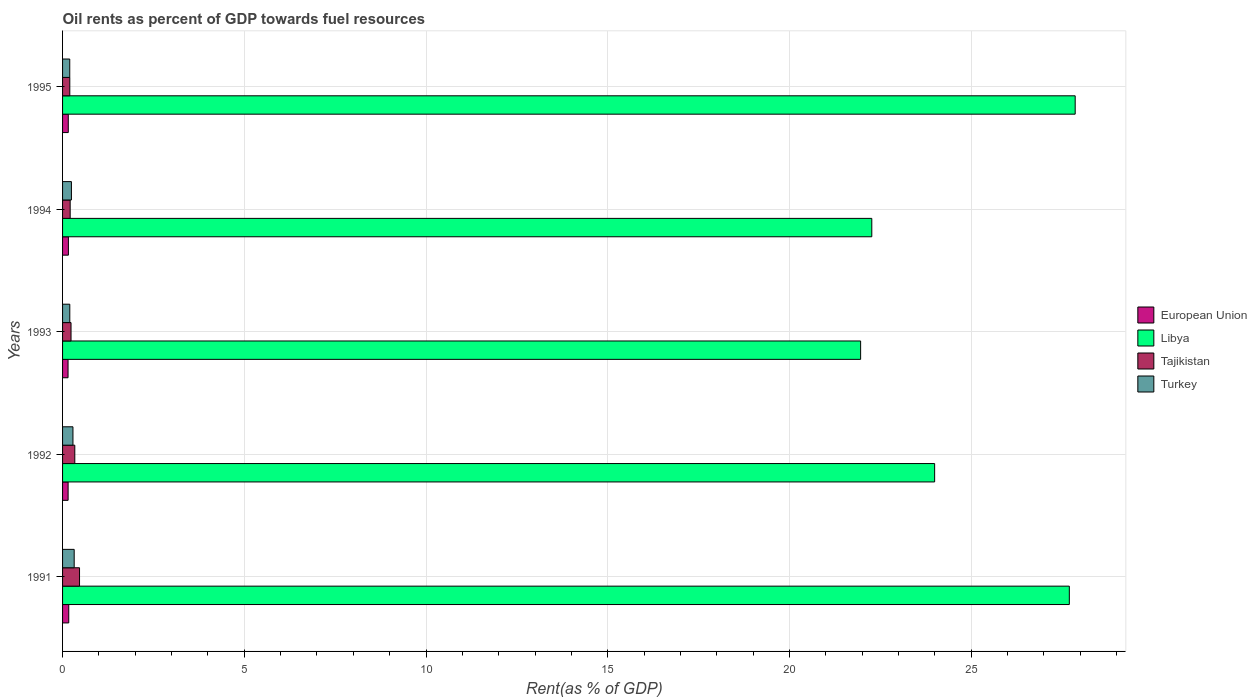How many different coloured bars are there?
Make the answer very short. 4. How many groups of bars are there?
Keep it short and to the point. 5. Are the number of bars per tick equal to the number of legend labels?
Ensure brevity in your answer.  Yes. What is the label of the 1st group of bars from the top?
Provide a short and direct response. 1995. What is the oil rent in Turkey in 1991?
Your response must be concise. 0.32. Across all years, what is the maximum oil rent in Tajikistan?
Ensure brevity in your answer.  0.47. Across all years, what is the minimum oil rent in Turkey?
Your answer should be compact. 0.2. In which year was the oil rent in Turkey minimum?
Provide a short and direct response. 1995. What is the total oil rent in Libya in the graph?
Offer a very short reply. 123.79. What is the difference between the oil rent in Tajikistan in 1993 and that in 1995?
Your answer should be compact. 0.03. What is the difference between the oil rent in Tajikistan in 1992 and the oil rent in Turkey in 1995?
Your answer should be compact. 0.14. What is the average oil rent in European Union per year?
Your answer should be very brief. 0.16. In the year 1993, what is the difference between the oil rent in European Union and oil rent in Libya?
Give a very brief answer. -21.81. In how many years, is the oil rent in European Union greater than 16 %?
Your answer should be very brief. 0. What is the ratio of the oil rent in Turkey in 1994 to that in 1995?
Make the answer very short. 1.23. Is the oil rent in European Union in 1991 less than that in 1992?
Offer a very short reply. No. What is the difference between the highest and the second highest oil rent in European Union?
Provide a succinct answer. 0.01. What is the difference between the highest and the lowest oil rent in Turkey?
Keep it short and to the point. 0.12. In how many years, is the oil rent in Turkey greater than the average oil rent in Turkey taken over all years?
Offer a very short reply. 2. What does the 2nd bar from the top in 1991 represents?
Ensure brevity in your answer.  Tajikistan. How many bars are there?
Your answer should be very brief. 20. Are the values on the major ticks of X-axis written in scientific E-notation?
Your response must be concise. No. Does the graph contain any zero values?
Your response must be concise. No. How are the legend labels stacked?
Your answer should be very brief. Vertical. What is the title of the graph?
Offer a terse response. Oil rents as percent of GDP towards fuel resources. Does "Japan" appear as one of the legend labels in the graph?
Your response must be concise. No. What is the label or title of the X-axis?
Offer a very short reply. Rent(as % of GDP). What is the label or title of the Y-axis?
Provide a succinct answer. Years. What is the Rent(as % of GDP) in European Union in 1991?
Offer a very short reply. 0.17. What is the Rent(as % of GDP) in Libya in 1991?
Give a very brief answer. 27.7. What is the Rent(as % of GDP) of Tajikistan in 1991?
Offer a very short reply. 0.47. What is the Rent(as % of GDP) of Turkey in 1991?
Your response must be concise. 0.32. What is the Rent(as % of GDP) in European Union in 1992?
Your answer should be very brief. 0.15. What is the Rent(as % of GDP) of Libya in 1992?
Give a very brief answer. 24. What is the Rent(as % of GDP) of Tajikistan in 1992?
Keep it short and to the point. 0.34. What is the Rent(as % of GDP) of Turkey in 1992?
Offer a very short reply. 0.29. What is the Rent(as % of GDP) in European Union in 1993?
Your answer should be compact. 0.15. What is the Rent(as % of GDP) in Libya in 1993?
Provide a short and direct response. 21.96. What is the Rent(as % of GDP) of Tajikistan in 1993?
Make the answer very short. 0.23. What is the Rent(as % of GDP) of Turkey in 1993?
Your answer should be compact. 0.2. What is the Rent(as % of GDP) in European Union in 1994?
Your answer should be compact. 0.16. What is the Rent(as % of GDP) in Libya in 1994?
Your response must be concise. 22.27. What is the Rent(as % of GDP) of Tajikistan in 1994?
Offer a very short reply. 0.21. What is the Rent(as % of GDP) of Turkey in 1994?
Provide a short and direct response. 0.24. What is the Rent(as % of GDP) in European Union in 1995?
Provide a succinct answer. 0.16. What is the Rent(as % of GDP) of Libya in 1995?
Offer a very short reply. 27.86. What is the Rent(as % of GDP) of Tajikistan in 1995?
Your response must be concise. 0.2. What is the Rent(as % of GDP) of Turkey in 1995?
Give a very brief answer. 0.2. Across all years, what is the maximum Rent(as % of GDP) in European Union?
Your response must be concise. 0.17. Across all years, what is the maximum Rent(as % of GDP) in Libya?
Your response must be concise. 27.86. Across all years, what is the maximum Rent(as % of GDP) in Tajikistan?
Keep it short and to the point. 0.47. Across all years, what is the maximum Rent(as % of GDP) in Turkey?
Provide a short and direct response. 0.32. Across all years, what is the minimum Rent(as % of GDP) in European Union?
Your response must be concise. 0.15. Across all years, what is the minimum Rent(as % of GDP) in Libya?
Offer a very short reply. 21.96. Across all years, what is the minimum Rent(as % of GDP) in Tajikistan?
Offer a very short reply. 0.2. Across all years, what is the minimum Rent(as % of GDP) of Turkey?
Your response must be concise. 0.2. What is the total Rent(as % of GDP) in European Union in the graph?
Offer a very short reply. 0.79. What is the total Rent(as % of GDP) of Libya in the graph?
Give a very brief answer. 123.79. What is the total Rent(as % of GDP) in Tajikistan in the graph?
Offer a very short reply. 1.44. What is the total Rent(as % of GDP) in Turkey in the graph?
Provide a succinct answer. 1.25. What is the difference between the Rent(as % of GDP) in European Union in 1991 and that in 1992?
Provide a short and direct response. 0.02. What is the difference between the Rent(as % of GDP) of Libya in 1991 and that in 1992?
Your answer should be compact. 3.71. What is the difference between the Rent(as % of GDP) of Tajikistan in 1991 and that in 1992?
Offer a very short reply. 0.13. What is the difference between the Rent(as % of GDP) in Turkey in 1991 and that in 1992?
Ensure brevity in your answer.  0.03. What is the difference between the Rent(as % of GDP) in European Union in 1991 and that in 1993?
Your answer should be compact. 0.02. What is the difference between the Rent(as % of GDP) in Libya in 1991 and that in 1993?
Your response must be concise. 5.74. What is the difference between the Rent(as % of GDP) in Tajikistan in 1991 and that in 1993?
Provide a short and direct response. 0.23. What is the difference between the Rent(as % of GDP) in Turkey in 1991 and that in 1993?
Provide a succinct answer. 0.12. What is the difference between the Rent(as % of GDP) in European Union in 1991 and that in 1994?
Offer a terse response. 0.01. What is the difference between the Rent(as % of GDP) of Libya in 1991 and that in 1994?
Your answer should be very brief. 5.43. What is the difference between the Rent(as % of GDP) in Tajikistan in 1991 and that in 1994?
Make the answer very short. 0.26. What is the difference between the Rent(as % of GDP) of Turkey in 1991 and that in 1994?
Your response must be concise. 0.08. What is the difference between the Rent(as % of GDP) in European Union in 1991 and that in 1995?
Your answer should be compact. 0.01. What is the difference between the Rent(as % of GDP) of Libya in 1991 and that in 1995?
Provide a succinct answer. -0.16. What is the difference between the Rent(as % of GDP) of Tajikistan in 1991 and that in 1995?
Offer a very short reply. 0.27. What is the difference between the Rent(as % of GDP) in Turkey in 1991 and that in 1995?
Give a very brief answer. 0.12. What is the difference between the Rent(as % of GDP) in European Union in 1992 and that in 1993?
Make the answer very short. 0. What is the difference between the Rent(as % of GDP) of Libya in 1992 and that in 1993?
Keep it short and to the point. 2.04. What is the difference between the Rent(as % of GDP) in Tajikistan in 1992 and that in 1993?
Your answer should be very brief. 0.1. What is the difference between the Rent(as % of GDP) of Turkey in 1992 and that in 1993?
Offer a terse response. 0.09. What is the difference between the Rent(as % of GDP) of European Union in 1992 and that in 1994?
Offer a very short reply. -0.01. What is the difference between the Rent(as % of GDP) in Libya in 1992 and that in 1994?
Your answer should be compact. 1.73. What is the difference between the Rent(as % of GDP) of Tajikistan in 1992 and that in 1994?
Keep it short and to the point. 0.13. What is the difference between the Rent(as % of GDP) in Turkey in 1992 and that in 1994?
Give a very brief answer. 0.04. What is the difference between the Rent(as % of GDP) in European Union in 1992 and that in 1995?
Your response must be concise. -0. What is the difference between the Rent(as % of GDP) of Libya in 1992 and that in 1995?
Your response must be concise. -3.87. What is the difference between the Rent(as % of GDP) of Tajikistan in 1992 and that in 1995?
Ensure brevity in your answer.  0.14. What is the difference between the Rent(as % of GDP) in Turkey in 1992 and that in 1995?
Ensure brevity in your answer.  0.09. What is the difference between the Rent(as % of GDP) of European Union in 1993 and that in 1994?
Ensure brevity in your answer.  -0.01. What is the difference between the Rent(as % of GDP) in Libya in 1993 and that in 1994?
Ensure brevity in your answer.  -0.31. What is the difference between the Rent(as % of GDP) of Tajikistan in 1993 and that in 1994?
Make the answer very short. 0.02. What is the difference between the Rent(as % of GDP) in Turkey in 1993 and that in 1994?
Make the answer very short. -0.04. What is the difference between the Rent(as % of GDP) of European Union in 1993 and that in 1995?
Provide a short and direct response. -0.01. What is the difference between the Rent(as % of GDP) of Libya in 1993 and that in 1995?
Your answer should be very brief. -5.9. What is the difference between the Rent(as % of GDP) of Tajikistan in 1993 and that in 1995?
Your answer should be very brief. 0.03. What is the difference between the Rent(as % of GDP) in Turkey in 1993 and that in 1995?
Keep it short and to the point. 0. What is the difference between the Rent(as % of GDP) of European Union in 1994 and that in 1995?
Your response must be concise. 0. What is the difference between the Rent(as % of GDP) in Libya in 1994 and that in 1995?
Your response must be concise. -5.6. What is the difference between the Rent(as % of GDP) of Tajikistan in 1994 and that in 1995?
Your answer should be very brief. 0.01. What is the difference between the Rent(as % of GDP) in Turkey in 1994 and that in 1995?
Your response must be concise. 0.05. What is the difference between the Rent(as % of GDP) in European Union in 1991 and the Rent(as % of GDP) in Libya in 1992?
Offer a terse response. -23.83. What is the difference between the Rent(as % of GDP) of European Union in 1991 and the Rent(as % of GDP) of Tajikistan in 1992?
Provide a short and direct response. -0.17. What is the difference between the Rent(as % of GDP) in European Union in 1991 and the Rent(as % of GDP) in Turkey in 1992?
Make the answer very short. -0.12. What is the difference between the Rent(as % of GDP) in Libya in 1991 and the Rent(as % of GDP) in Tajikistan in 1992?
Your answer should be very brief. 27.37. What is the difference between the Rent(as % of GDP) in Libya in 1991 and the Rent(as % of GDP) in Turkey in 1992?
Ensure brevity in your answer.  27.42. What is the difference between the Rent(as % of GDP) in Tajikistan in 1991 and the Rent(as % of GDP) in Turkey in 1992?
Provide a succinct answer. 0.18. What is the difference between the Rent(as % of GDP) of European Union in 1991 and the Rent(as % of GDP) of Libya in 1993?
Offer a very short reply. -21.79. What is the difference between the Rent(as % of GDP) of European Union in 1991 and the Rent(as % of GDP) of Tajikistan in 1993?
Ensure brevity in your answer.  -0.06. What is the difference between the Rent(as % of GDP) of European Union in 1991 and the Rent(as % of GDP) of Turkey in 1993?
Make the answer very short. -0.03. What is the difference between the Rent(as % of GDP) in Libya in 1991 and the Rent(as % of GDP) in Tajikistan in 1993?
Keep it short and to the point. 27.47. What is the difference between the Rent(as % of GDP) in Libya in 1991 and the Rent(as % of GDP) in Turkey in 1993?
Offer a terse response. 27.5. What is the difference between the Rent(as % of GDP) of Tajikistan in 1991 and the Rent(as % of GDP) of Turkey in 1993?
Ensure brevity in your answer.  0.27. What is the difference between the Rent(as % of GDP) of European Union in 1991 and the Rent(as % of GDP) of Libya in 1994?
Your answer should be compact. -22.1. What is the difference between the Rent(as % of GDP) of European Union in 1991 and the Rent(as % of GDP) of Tajikistan in 1994?
Make the answer very short. -0.04. What is the difference between the Rent(as % of GDP) of European Union in 1991 and the Rent(as % of GDP) of Turkey in 1994?
Ensure brevity in your answer.  -0.07. What is the difference between the Rent(as % of GDP) of Libya in 1991 and the Rent(as % of GDP) of Tajikistan in 1994?
Offer a terse response. 27.49. What is the difference between the Rent(as % of GDP) of Libya in 1991 and the Rent(as % of GDP) of Turkey in 1994?
Make the answer very short. 27.46. What is the difference between the Rent(as % of GDP) in Tajikistan in 1991 and the Rent(as % of GDP) in Turkey in 1994?
Ensure brevity in your answer.  0.22. What is the difference between the Rent(as % of GDP) of European Union in 1991 and the Rent(as % of GDP) of Libya in 1995?
Your response must be concise. -27.69. What is the difference between the Rent(as % of GDP) in European Union in 1991 and the Rent(as % of GDP) in Tajikistan in 1995?
Your response must be concise. -0.03. What is the difference between the Rent(as % of GDP) of European Union in 1991 and the Rent(as % of GDP) of Turkey in 1995?
Ensure brevity in your answer.  -0.03. What is the difference between the Rent(as % of GDP) in Libya in 1991 and the Rent(as % of GDP) in Tajikistan in 1995?
Ensure brevity in your answer.  27.5. What is the difference between the Rent(as % of GDP) in Libya in 1991 and the Rent(as % of GDP) in Turkey in 1995?
Your response must be concise. 27.5. What is the difference between the Rent(as % of GDP) in Tajikistan in 1991 and the Rent(as % of GDP) in Turkey in 1995?
Ensure brevity in your answer.  0.27. What is the difference between the Rent(as % of GDP) of European Union in 1992 and the Rent(as % of GDP) of Libya in 1993?
Your answer should be very brief. -21.81. What is the difference between the Rent(as % of GDP) of European Union in 1992 and the Rent(as % of GDP) of Tajikistan in 1993?
Provide a succinct answer. -0.08. What is the difference between the Rent(as % of GDP) in European Union in 1992 and the Rent(as % of GDP) in Turkey in 1993?
Offer a very short reply. -0.05. What is the difference between the Rent(as % of GDP) of Libya in 1992 and the Rent(as % of GDP) of Tajikistan in 1993?
Your response must be concise. 23.76. What is the difference between the Rent(as % of GDP) of Libya in 1992 and the Rent(as % of GDP) of Turkey in 1993?
Give a very brief answer. 23.8. What is the difference between the Rent(as % of GDP) in Tajikistan in 1992 and the Rent(as % of GDP) in Turkey in 1993?
Give a very brief answer. 0.14. What is the difference between the Rent(as % of GDP) in European Union in 1992 and the Rent(as % of GDP) in Libya in 1994?
Ensure brevity in your answer.  -22.11. What is the difference between the Rent(as % of GDP) in European Union in 1992 and the Rent(as % of GDP) in Tajikistan in 1994?
Give a very brief answer. -0.06. What is the difference between the Rent(as % of GDP) in European Union in 1992 and the Rent(as % of GDP) in Turkey in 1994?
Make the answer very short. -0.09. What is the difference between the Rent(as % of GDP) in Libya in 1992 and the Rent(as % of GDP) in Tajikistan in 1994?
Your answer should be compact. 23.79. What is the difference between the Rent(as % of GDP) of Libya in 1992 and the Rent(as % of GDP) of Turkey in 1994?
Keep it short and to the point. 23.75. What is the difference between the Rent(as % of GDP) in Tajikistan in 1992 and the Rent(as % of GDP) in Turkey in 1994?
Provide a succinct answer. 0.09. What is the difference between the Rent(as % of GDP) in European Union in 1992 and the Rent(as % of GDP) in Libya in 1995?
Provide a short and direct response. -27.71. What is the difference between the Rent(as % of GDP) of European Union in 1992 and the Rent(as % of GDP) of Tajikistan in 1995?
Make the answer very short. -0.05. What is the difference between the Rent(as % of GDP) of European Union in 1992 and the Rent(as % of GDP) of Turkey in 1995?
Ensure brevity in your answer.  -0.04. What is the difference between the Rent(as % of GDP) in Libya in 1992 and the Rent(as % of GDP) in Tajikistan in 1995?
Provide a short and direct response. 23.8. What is the difference between the Rent(as % of GDP) in Libya in 1992 and the Rent(as % of GDP) in Turkey in 1995?
Ensure brevity in your answer.  23.8. What is the difference between the Rent(as % of GDP) of Tajikistan in 1992 and the Rent(as % of GDP) of Turkey in 1995?
Provide a succinct answer. 0.14. What is the difference between the Rent(as % of GDP) in European Union in 1993 and the Rent(as % of GDP) in Libya in 1994?
Keep it short and to the point. -22.12. What is the difference between the Rent(as % of GDP) of European Union in 1993 and the Rent(as % of GDP) of Tajikistan in 1994?
Your answer should be very brief. -0.06. What is the difference between the Rent(as % of GDP) of European Union in 1993 and the Rent(as % of GDP) of Turkey in 1994?
Provide a short and direct response. -0.09. What is the difference between the Rent(as % of GDP) of Libya in 1993 and the Rent(as % of GDP) of Tajikistan in 1994?
Make the answer very short. 21.75. What is the difference between the Rent(as % of GDP) in Libya in 1993 and the Rent(as % of GDP) in Turkey in 1994?
Give a very brief answer. 21.72. What is the difference between the Rent(as % of GDP) of Tajikistan in 1993 and the Rent(as % of GDP) of Turkey in 1994?
Make the answer very short. -0.01. What is the difference between the Rent(as % of GDP) in European Union in 1993 and the Rent(as % of GDP) in Libya in 1995?
Keep it short and to the point. -27.71. What is the difference between the Rent(as % of GDP) in European Union in 1993 and the Rent(as % of GDP) in Tajikistan in 1995?
Offer a terse response. -0.05. What is the difference between the Rent(as % of GDP) in European Union in 1993 and the Rent(as % of GDP) in Turkey in 1995?
Provide a succinct answer. -0.05. What is the difference between the Rent(as % of GDP) in Libya in 1993 and the Rent(as % of GDP) in Tajikistan in 1995?
Provide a succinct answer. 21.76. What is the difference between the Rent(as % of GDP) in Libya in 1993 and the Rent(as % of GDP) in Turkey in 1995?
Your response must be concise. 21.76. What is the difference between the Rent(as % of GDP) of Tajikistan in 1993 and the Rent(as % of GDP) of Turkey in 1995?
Your response must be concise. 0.04. What is the difference between the Rent(as % of GDP) of European Union in 1994 and the Rent(as % of GDP) of Libya in 1995?
Offer a terse response. -27.7. What is the difference between the Rent(as % of GDP) in European Union in 1994 and the Rent(as % of GDP) in Tajikistan in 1995?
Provide a short and direct response. -0.04. What is the difference between the Rent(as % of GDP) of European Union in 1994 and the Rent(as % of GDP) of Turkey in 1995?
Keep it short and to the point. -0.04. What is the difference between the Rent(as % of GDP) of Libya in 1994 and the Rent(as % of GDP) of Tajikistan in 1995?
Give a very brief answer. 22.07. What is the difference between the Rent(as % of GDP) of Libya in 1994 and the Rent(as % of GDP) of Turkey in 1995?
Your response must be concise. 22.07. What is the difference between the Rent(as % of GDP) in Tajikistan in 1994 and the Rent(as % of GDP) in Turkey in 1995?
Provide a short and direct response. 0.01. What is the average Rent(as % of GDP) in European Union per year?
Make the answer very short. 0.16. What is the average Rent(as % of GDP) of Libya per year?
Keep it short and to the point. 24.76. What is the average Rent(as % of GDP) in Tajikistan per year?
Make the answer very short. 0.29. What is the average Rent(as % of GDP) of Turkey per year?
Give a very brief answer. 0.25. In the year 1991, what is the difference between the Rent(as % of GDP) in European Union and Rent(as % of GDP) in Libya?
Your answer should be compact. -27.53. In the year 1991, what is the difference between the Rent(as % of GDP) of European Union and Rent(as % of GDP) of Tajikistan?
Keep it short and to the point. -0.3. In the year 1991, what is the difference between the Rent(as % of GDP) of European Union and Rent(as % of GDP) of Turkey?
Your response must be concise. -0.15. In the year 1991, what is the difference between the Rent(as % of GDP) in Libya and Rent(as % of GDP) in Tajikistan?
Keep it short and to the point. 27.23. In the year 1991, what is the difference between the Rent(as % of GDP) in Libya and Rent(as % of GDP) in Turkey?
Keep it short and to the point. 27.38. In the year 1991, what is the difference between the Rent(as % of GDP) in Tajikistan and Rent(as % of GDP) in Turkey?
Offer a terse response. 0.15. In the year 1992, what is the difference between the Rent(as % of GDP) in European Union and Rent(as % of GDP) in Libya?
Offer a very short reply. -23.84. In the year 1992, what is the difference between the Rent(as % of GDP) in European Union and Rent(as % of GDP) in Tajikistan?
Offer a terse response. -0.18. In the year 1992, what is the difference between the Rent(as % of GDP) in European Union and Rent(as % of GDP) in Turkey?
Provide a short and direct response. -0.13. In the year 1992, what is the difference between the Rent(as % of GDP) of Libya and Rent(as % of GDP) of Tajikistan?
Give a very brief answer. 23.66. In the year 1992, what is the difference between the Rent(as % of GDP) of Libya and Rent(as % of GDP) of Turkey?
Ensure brevity in your answer.  23.71. In the year 1992, what is the difference between the Rent(as % of GDP) of Tajikistan and Rent(as % of GDP) of Turkey?
Offer a very short reply. 0.05. In the year 1993, what is the difference between the Rent(as % of GDP) in European Union and Rent(as % of GDP) in Libya?
Ensure brevity in your answer.  -21.81. In the year 1993, what is the difference between the Rent(as % of GDP) of European Union and Rent(as % of GDP) of Tajikistan?
Give a very brief answer. -0.08. In the year 1993, what is the difference between the Rent(as % of GDP) of European Union and Rent(as % of GDP) of Turkey?
Provide a short and direct response. -0.05. In the year 1993, what is the difference between the Rent(as % of GDP) of Libya and Rent(as % of GDP) of Tajikistan?
Your answer should be compact. 21.73. In the year 1993, what is the difference between the Rent(as % of GDP) in Libya and Rent(as % of GDP) in Turkey?
Offer a terse response. 21.76. In the year 1993, what is the difference between the Rent(as % of GDP) in Tajikistan and Rent(as % of GDP) in Turkey?
Your answer should be compact. 0.03. In the year 1994, what is the difference between the Rent(as % of GDP) in European Union and Rent(as % of GDP) in Libya?
Provide a succinct answer. -22.11. In the year 1994, what is the difference between the Rent(as % of GDP) in European Union and Rent(as % of GDP) in Tajikistan?
Your response must be concise. -0.05. In the year 1994, what is the difference between the Rent(as % of GDP) in European Union and Rent(as % of GDP) in Turkey?
Your response must be concise. -0.08. In the year 1994, what is the difference between the Rent(as % of GDP) in Libya and Rent(as % of GDP) in Tajikistan?
Provide a short and direct response. 22.06. In the year 1994, what is the difference between the Rent(as % of GDP) of Libya and Rent(as % of GDP) of Turkey?
Your answer should be compact. 22.02. In the year 1994, what is the difference between the Rent(as % of GDP) of Tajikistan and Rent(as % of GDP) of Turkey?
Offer a terse response. -0.03. In the year 1995, what is the difference between the Rent(as % of GDP) of European Union and Rent(as % of GDP) of Libya?
Provide a succinct answer. -27.71. In the year 1995, what is the difference between the Rent(as % of GDP) in European Union and Rent(as % of GDP) in Tajikistan?
Your response must be concise. -0.04. In the year 1995, what is the difference between the Rent(as % of GDP) of European Union and Rent(as % of GDP) of Turkey?
Ensure brevity in your answer.  -0.04. In the year 1995, what is the difference between the Rent(as % of GDP) in Libya and Rent(as % of GDP) in Tajikistan?
Give a very brief answer. 27.66. In the year 1995, what is the difference between the Rent(as % of GDP) in Libya and Rent(as % of GDP) in Turkey?
Give a very brief answer. 27.67. In the year 1995, what is the difference between the Rent(as % of GDP) of Tajikistan and Rent(as % of GDP) of Turkey?
Your response must be concise. 0. What is the ratio of the Rent(as % of GDP) of European Union in 1991 to that in 1992?
Your response must be concise. 1.11. What is the ratio of the Rent(as % of GDP) of Libya in 1991 to that in 1992?
Ensure brevity in your answer.  1.15. What is the ratio of the Rent(as % of GDP) in Tajikistan in 1991 to that in 1992?
Keep it short and to the point. 1.39. What is the ratio of the Rent(as % of GDP) in Turkey in 1991 to that in 1992?
Make the answer very short. 1.12. What is the ratio of the Rent(as % of GDP) in European Union in 1991 to that in 1993?
Provide a succinct answer. 1.13. What is the ratio of the Rent(as % of GDP) of Libya in 1991 to that in 1993?
Offer a terse response. 1.26. What is the ratio of the Rent(as % of GDP) of Tajikistan in 1991 to that in 1993?
Give a very brief answer. 2. What is the ratio of the Rent(as % of GDP) in Turkey in 1991 to that in 1993?
Keep it short and to the point. 1.61. What is the ratio of the Rent(as % of GDP) in European Union in 1991 to that in 1994?
Your response must be concise. 1.06. What is the ratio of the Rent(as % of GDP) of Libya in 1991 to that in 1994?
Provide a succinct answer. 1.24. What is the ratio of the Rent(as % of GDP) in Tajikistan in 1991 to that in 1994?
Your answer should be compact. 2.23. What is the ratio of the Rent(as % of GDP) of Turkey in 1991 to that in 1994?
Offer a terse response. 1.31. What is the ratio of the Rent(as % of GDP) in European Union in 1991 to that in 1995?
Your response must be concise. 1.08. What is the ratio of the Rent(as % of GDP) of Libya in 1991 to that in 1995?
Offer a terse response. 0.99. What is the ratio of the Rent(as % of GDP) in Tajikistan in 1991 to that in 1995?
Make the answer very short. 2.35. What is the ratio of the Rent(as % of GDP) of Turkey in 1991 to that in 1995?
Your answer should be very brief. 1.62. What is the ratio of the Rent(as % of GDP) in European Union in 1992 to that in 1993?
Your answer should be compact. 1.01. What is the ratio of the Rent(as % of GDP) in Libya in 1992 to that in 1993?
Your response must be concise. 1.09. What is the ratio of the Rent(as % of GDP) of Tajikistan in 1992 to that in 1993?
Your response must be concise. 1.44. What is the ratio of the Rent(as % of GDP) in Turkey in 1992 to that in 1993?
Give a very brief answer. 1.44. What is the ratio of the Rent(as % of GDP) in European Union in 1992 to that in 1994?
Provide a succinct answer. 0.95. What is the ratio of the Rent(as % of GDP) in Libya in 1992 to that in 1994?
Give a very brief answer. 1.08. What is the ratio of the Rent(as % of GDP) in Tajikistan in 1992 to that in 1994?
Your answer should be compact. 1.61. What is the ratio of the Rent(as % of GDP) of Turkey in 1992 to that in 1994?
Your answer should be very brief. 1.17. What is the ratio of the Rent(as % of GDP) of European Union in 1992 to that in 1995?
Make the answer very short. 0.97. What is the ratio of the Rent(as % of GDP) of Libya in 1992 to that in 1995?
Your response must be concise. 0.86. What is the ratio of the Rent(as % of GDP) of Tajikistan in 1992 to that in 1995?
Ensure brevity in your answer.  1.69. What is the ratio of the Rent(as % of GDP) of Turkey in 1992 to that in 1995?
Offer a very short reply. 1.45. What is the ratio of the Rent(as % of GDP) in European Union in 1993 to that in 1994?
Make the answer very short. 0.94. What is the ratio of the Rent(as % of GDP) in Libya in 1993 to that in 1994?
Make the answer very short. 0.99. What is the ratio of the Rent(as % of GDP) in Tajikistan in 1993 to that in 1994?
Ensure brevity in your answer.  1.11. What is the ratio of the Rent(as % of GDP) in Turkey in 1993 to that in 1994?
Make the answer very short. 0.82. What is the ratio of the Rent(as % of GDP) in European Union in 1993 to that in 1995?
Give a very brief answer. 0.96. What is the ratio of the Rent(as % of GDP) of Libya in 1993 to that in 1995?
Your response must be concise. 0.79. What is the ratio of the Rent(as % of GDP) of Tajikistan in 1993 to that in 1995?
Your answer should be very brief. 1.17. What is the ratio of the Rent(as % of GDP) of Turkey in 1993 to that in 1995?
Your response must be concise. 1.01. What is the ratio of the Rent(as % of GDP) in European Union in 1994 to that in 1995?
Make the answer very short. 1.02. What is the ratio of the Rent(as % of GDP) of Libya in 1994 to that in 1995?
Keep it short and to the point. 0.8. What is the ratio of the Rent(as % of GDP) of Tajikistan in 1994 to that in 1995?
Your answer should be very brief. 1.05. What is the ratio of the Rent(as % of GDP) in Turkey in 1994 to that in 1995?
Offer a terse response. 1.23. What is the difference between the highest and the second highest Rent(as % of GDP) of European Union?
Make the answer very short. 0.01. What is the difference between the highest and the second highest Rent(as % of GDP) in Libya?
Keep it short and to the point. 0.16. What is the difference between the highest and the second highest Rent(as % of GDP) of Tajikistan?
Your answer should be very brief. 0.13. What is the difference between the highest and the second highest Rent(as % of GDP) of Turkey?
Give a very brief answer. 0.03. What is the difference between the highest and the lowest Rent(as % of GDP) in European Union?
Offer a terse response. 0.02. What is the difference between the highest and the lowest Rent(as % of GDP) of Libya?
Provide a succinct answer. 5.9. What is the difference between the highest and the lowest Rent(as % of GDP) in Tajikistan?
Offer a very short reply. 0.27. What is the difference between the highest and the lowest Rent(as % of GDP) of Turkey?
Keep it short and to the point. 0.12. 